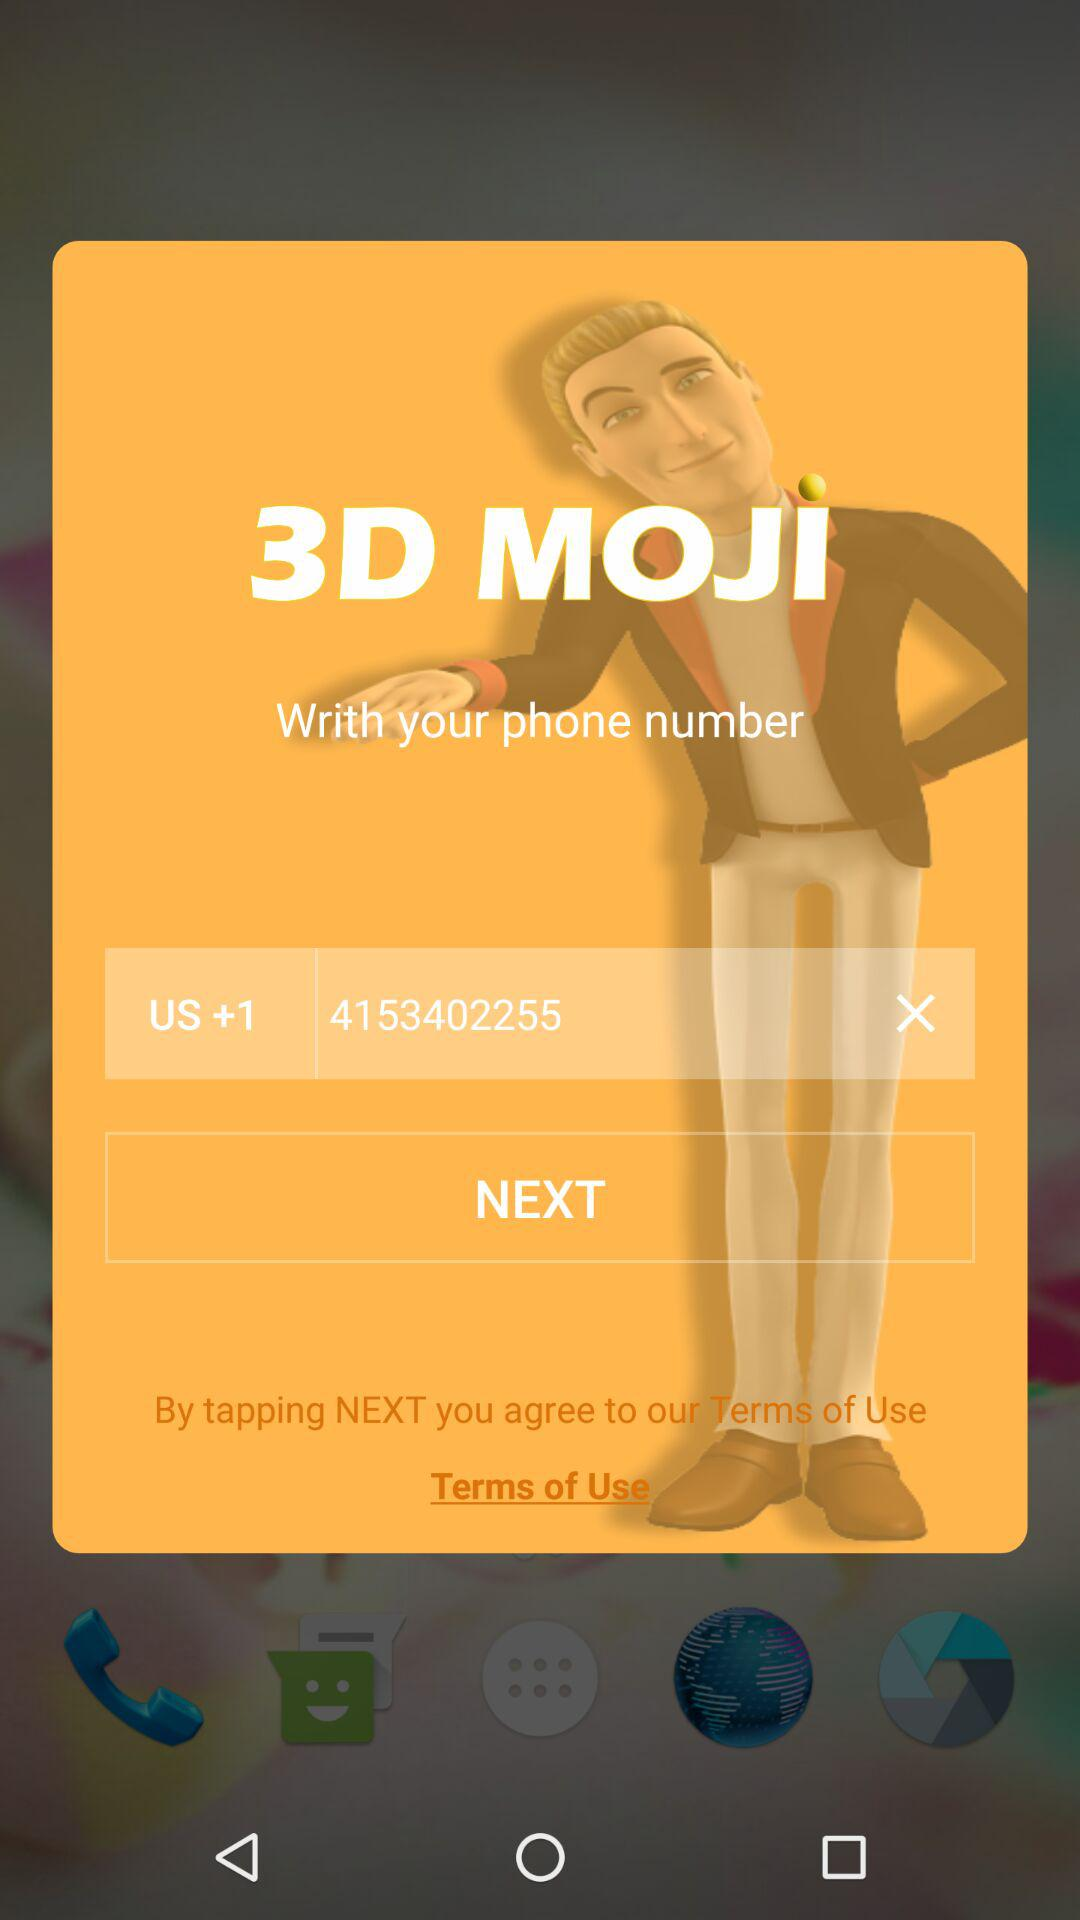What is the application name? The application name is "3D MOJI". 